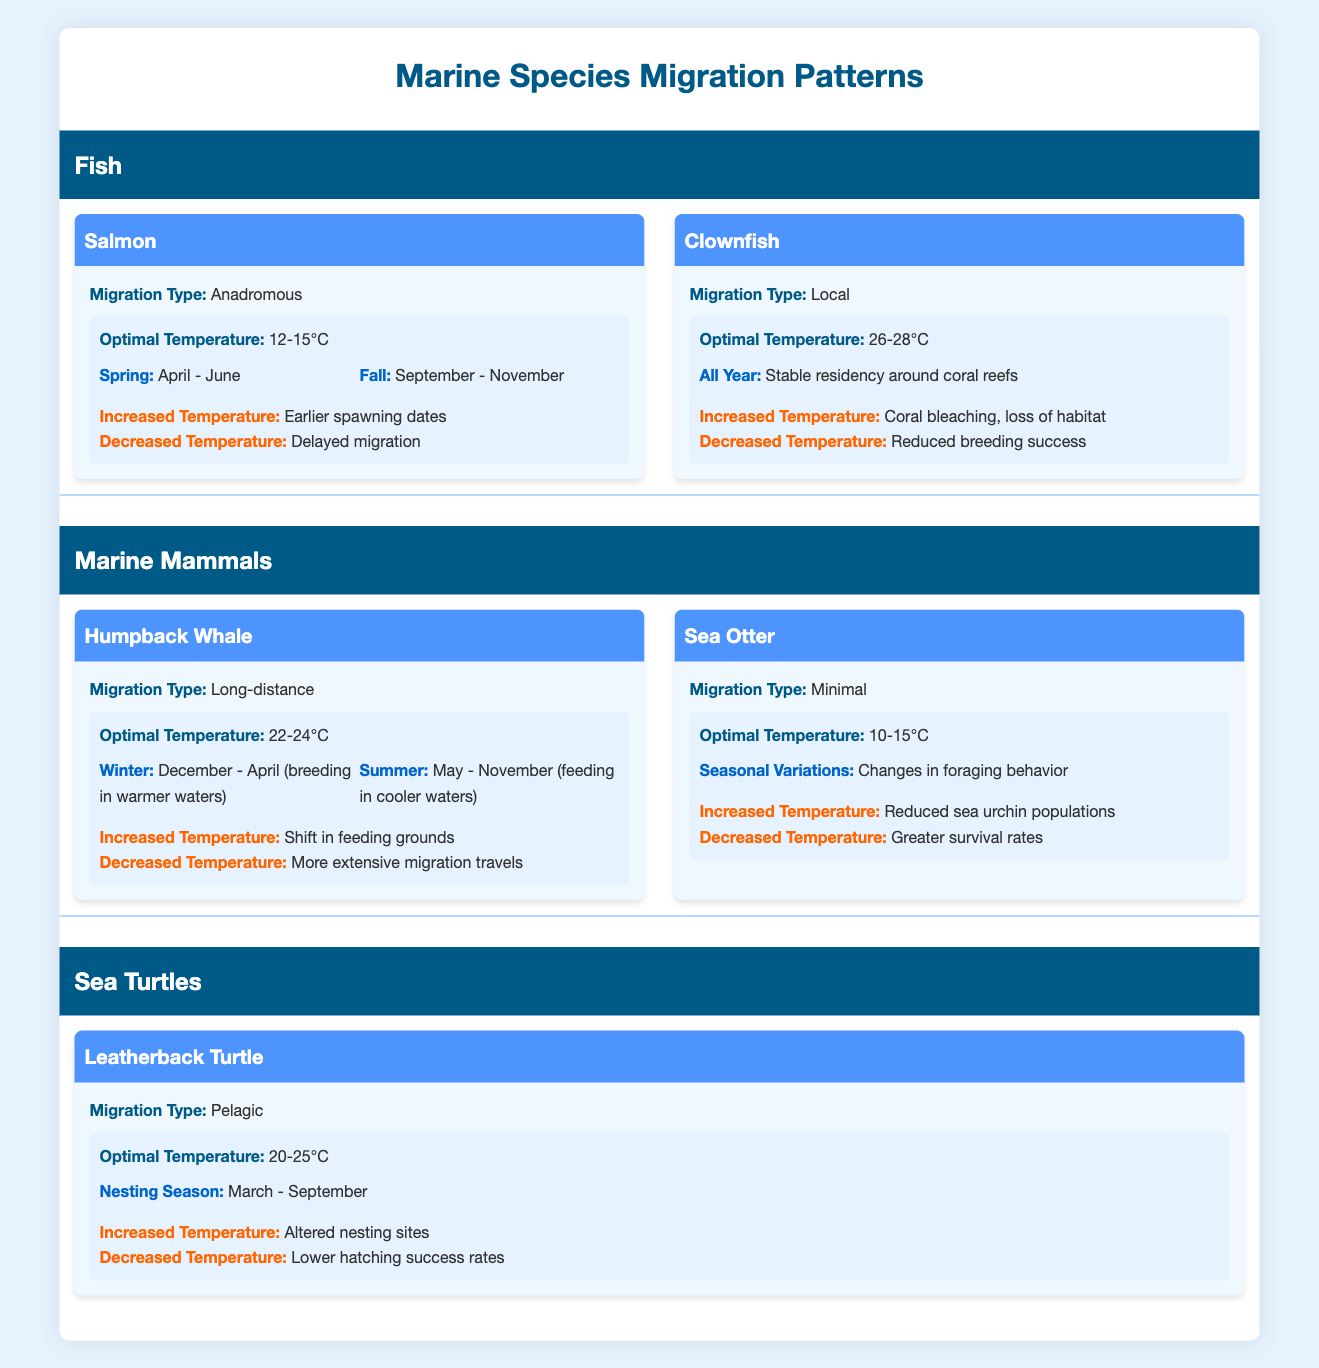What is the optimal temperature range for Salmon migration? From the table, the optimal temperature range for Salmon migration is provided under the "TemperatureImpact" section specifically indicating "OptimalTemperature: 12-15°C."
Answer: 12-15°C During which months does the Humpback Whale migrate for breeding? The table specifies Humpback Whale migration timings, stating "Winter: December - April (breeding in warmer waters)." Therefore, the months for breeding migration are December to April.
Answer: December - April What happens to Clownfish populations when the temperature increases? According to the data for Clownfish, there is a mention of "IncreasedTemperature: Coral bleaching, loss of habitat," indicating that higher temperatures negatively affect Clownfish populations.
Answer: Coral bleaching, loss of habitat If the temperature decreases, how would it affect the migration timing of Salmon? For Salmon, the response to decreased temperature is stated as "Delayed migration." This indicates that a drop in temperature would push back their migration period.
Answer: Delayed migration Do Leatherback Turtles nest all year round? The table shows "NestingSeason: March - September" for Leatherback Turtles, clearly indicating that they do not nest throughout the entire year. Therefore, the answer to this question is no.
Answer: No What is the difference in optimal temperature between Clownfish and Sea Otter? The optimal temperature for Clownfish is "26-28°C" and for Sea Otter is "10-15°C." The difference can be calculated by taking the lower and upper bounds: (26-10) and (28-15) which results in 16°C and 13°C respectively. Thus, the temperature difference varies depending on the extremes.
Answer: 13°C to 16°C How do increased temperatures affect the nesting sites of Leatherback Turtles? The data for Leatherback Turtles mentions that "IncreasedTemperature: Altered nesting sites," meaning that rises in temperature lead to changes in where they lay their eggs.
Answer: Altered nesting sites What migration type do Sea Otters exhibit? The table explicitly states the migration type for Sea Otters as "Minimal," indicating they do not undertake significant migration compared to other species.
Answer: Minimal What would be the response of Humpback Whales to increased ocean temperatures? According to the table, for Humpback Whales, increased temperatures lead to a "Shift in feeding grounds," which suggests a notable behavioral change as a response to environmental conditions.
Answer: Shift in feeding grounds 